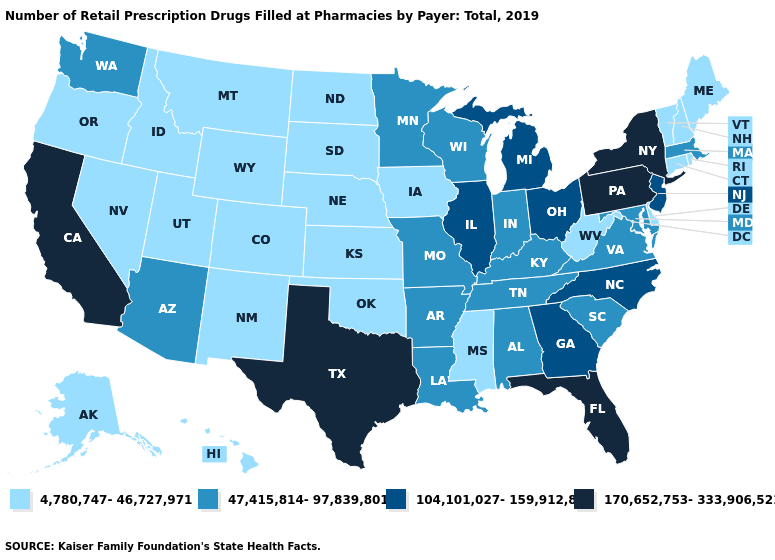Which states have the lowest value in the USA?
Keep it brief. Alaska, Colorado, Connecticut, Delaware, Hawaii, Idaho, Iowa, Kansas, Maine, Mississippi, Montana, Nebraska, Nevada, New Hampshire, New Mexico, North Dakota, Oklahoma, Oregon, Rhode Island, South Dakota, Utah, Vermont, West Virginia, Wyoming. Does the first symbol in the legend represent the smallest category?
Keep it brief. Yes. Name the states that have a value in the range 104,101,027-159,912,863?
Answer briefly. Georgia, Illinois, Michigan, New Jersey, North Carolina, Ohio. Name the states that have a value in the range 4,780,747-46,727,971?
Concise answer only. Alaska, Colorado, Connecticut, Delaware, Hawaii, Idaho, Iowa, Kansas, Maine, Mississippi, Montana, Nebraska, Nevada, New Hampshire, New Mexico, North Dakota, Oklahoma, Oregon, Rhode Island, South Dakota, Utah, Vermont, West Virginia, Wyoming. Name the states that have a value in the range 47,415,814-97,839,801?
Be succinct. Alabama, Arizona, Arkansas, Indiana, Kentucky, Louisiana, Maryland, Massachusetts, Minnesota, Missouri, South Carolina, Tennessee, Virginia, Washington, Wisconsin. Name the states that have a value in the range 4,780,747-46,727,971?
Write a very short answer. Alaska, Colorado, Connecticut, Delaware, Hawaii, Idaho, Iowa, Kansas, Maine, Mississippi, Montana, Nebraska, Nevada, New Hampshire, New Mexico, North Dakota, Oklahoma, Oregon, Rhode Island, South Dakota, Utah, Vermont, West Virginia, Wyoming. Does Ohio have the highest value in the MidWest?
Concise answer only. Yes. What is the value of Rhode Island?
Answer briefly. 4,780,747-46,727,971. Which states have the lowest value in the South?
Be succinct. Delaware, Mississippi, Oklahoma, West Virginia. What is the value of Arizona?
Quick response, please. 47,415,814-97,839,801. Does Pennsylvania have the highest value in the USA?
Answer briefly. Yes. Does the first symbol in the legend represent the smallest category?
Short answer required. Yes. Name the states that have a value in the range 170,652,753-333,906,521?
Answer briefly. California, Florida, New York, Pennsylvania, Texas. Does the map have missing data?
Give a very brief answer. No. What is the value of Rhode Island?
Give a very brief answer. 4,780,747-46,727,971. 